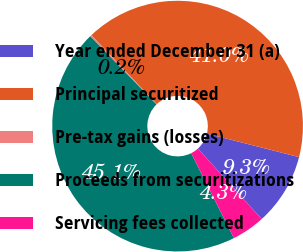Convert chart to OTSL. <chart><loc_0><loc_0><loc_500><loc_500><pie_chart><fcel>Year ended December 31 (a)<fcel>Principal securitized<fcel>Pre-tax gains (losses)<fcel>Proceeds from securitizations<fcel>Servicing fees collected<nl><fcel>9.32%<fcel>41.05%<fcel>0.2%<fcel>45.14%<fcel>4.29%<nl></chart> 